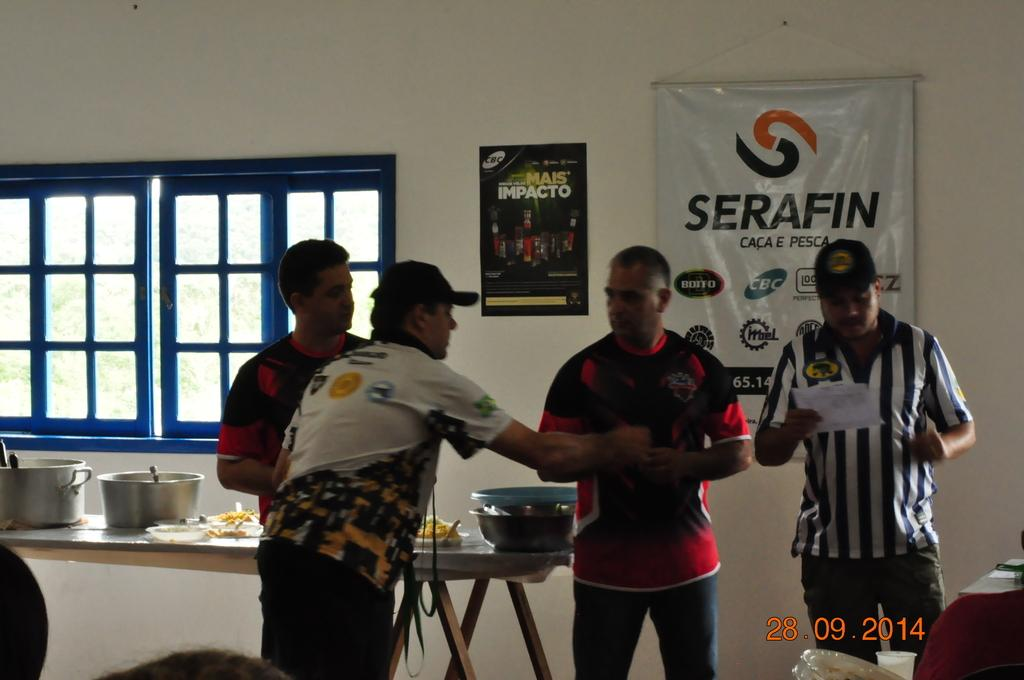<image>
Share a concise interpretation of the image provided. Four men appear to be having a heated conversation in front of a poster for Serafin. 